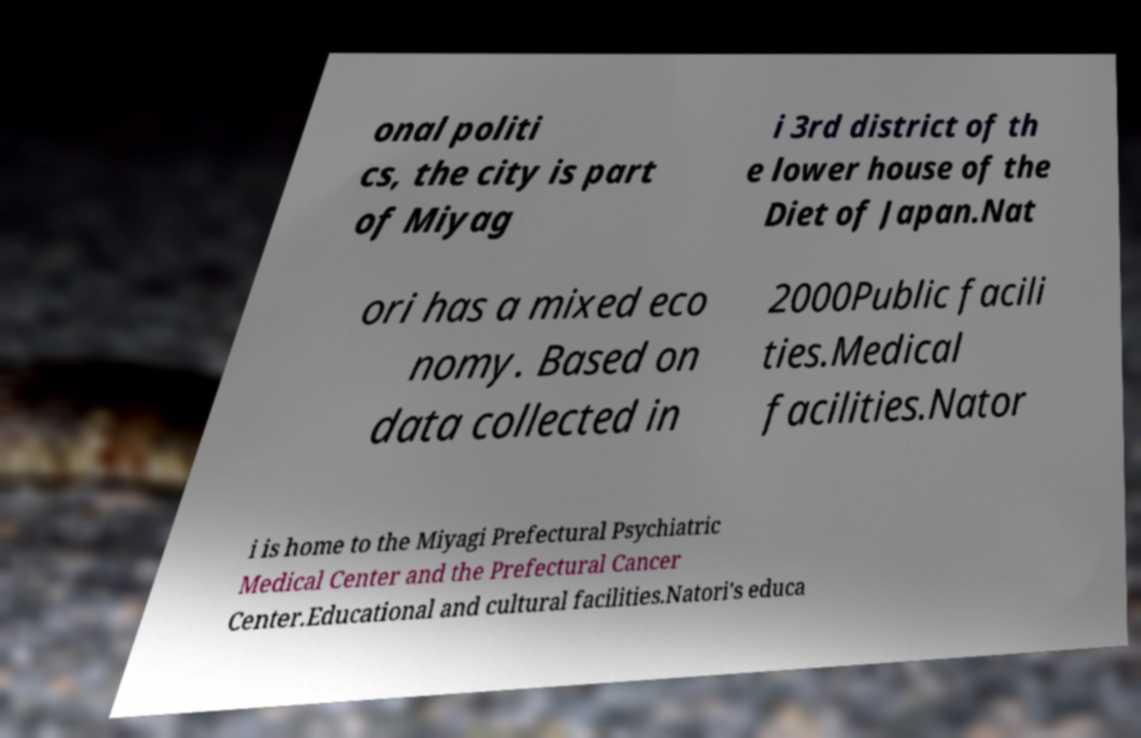Please read and relay the text visible in this image. What does it say? onal politi cs, the city is part of Miyag i 3rd district of th e lower house of the Diet of Japan.Nat ori has a mixed eco nomy. Based on data collected in 2000Public facili ties.Medical facilities.Nator i is home to the Miyagi Prefectural Psychiatric Medical Center and the Prefectural Cancer Center.Educational and cultural facilities.Natori's educa 